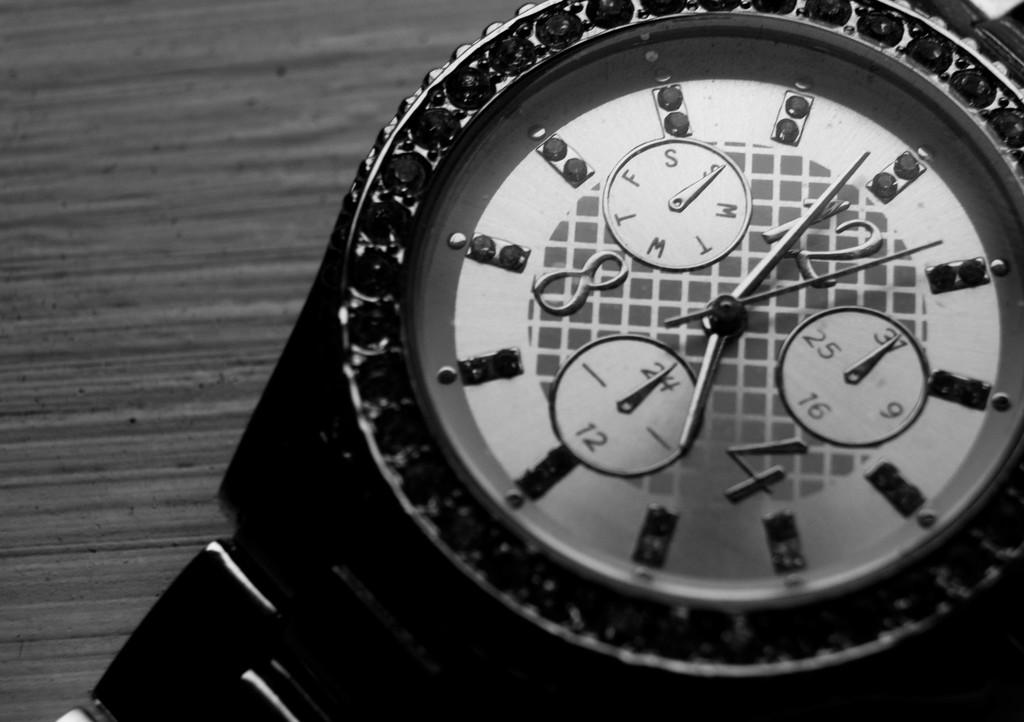What is the color scheme of the image? The image is black and white. What type of furniture is present in the image? There is a table in the image. What object is placed on the table? There is a watch on the table. What type of canvas is visible in the image? There is no canvas present in the image. What do you believe the watch represents in the image? The purpose or representation of the watch cannot be determined from the image alone, as it is a subjective interpretation. 